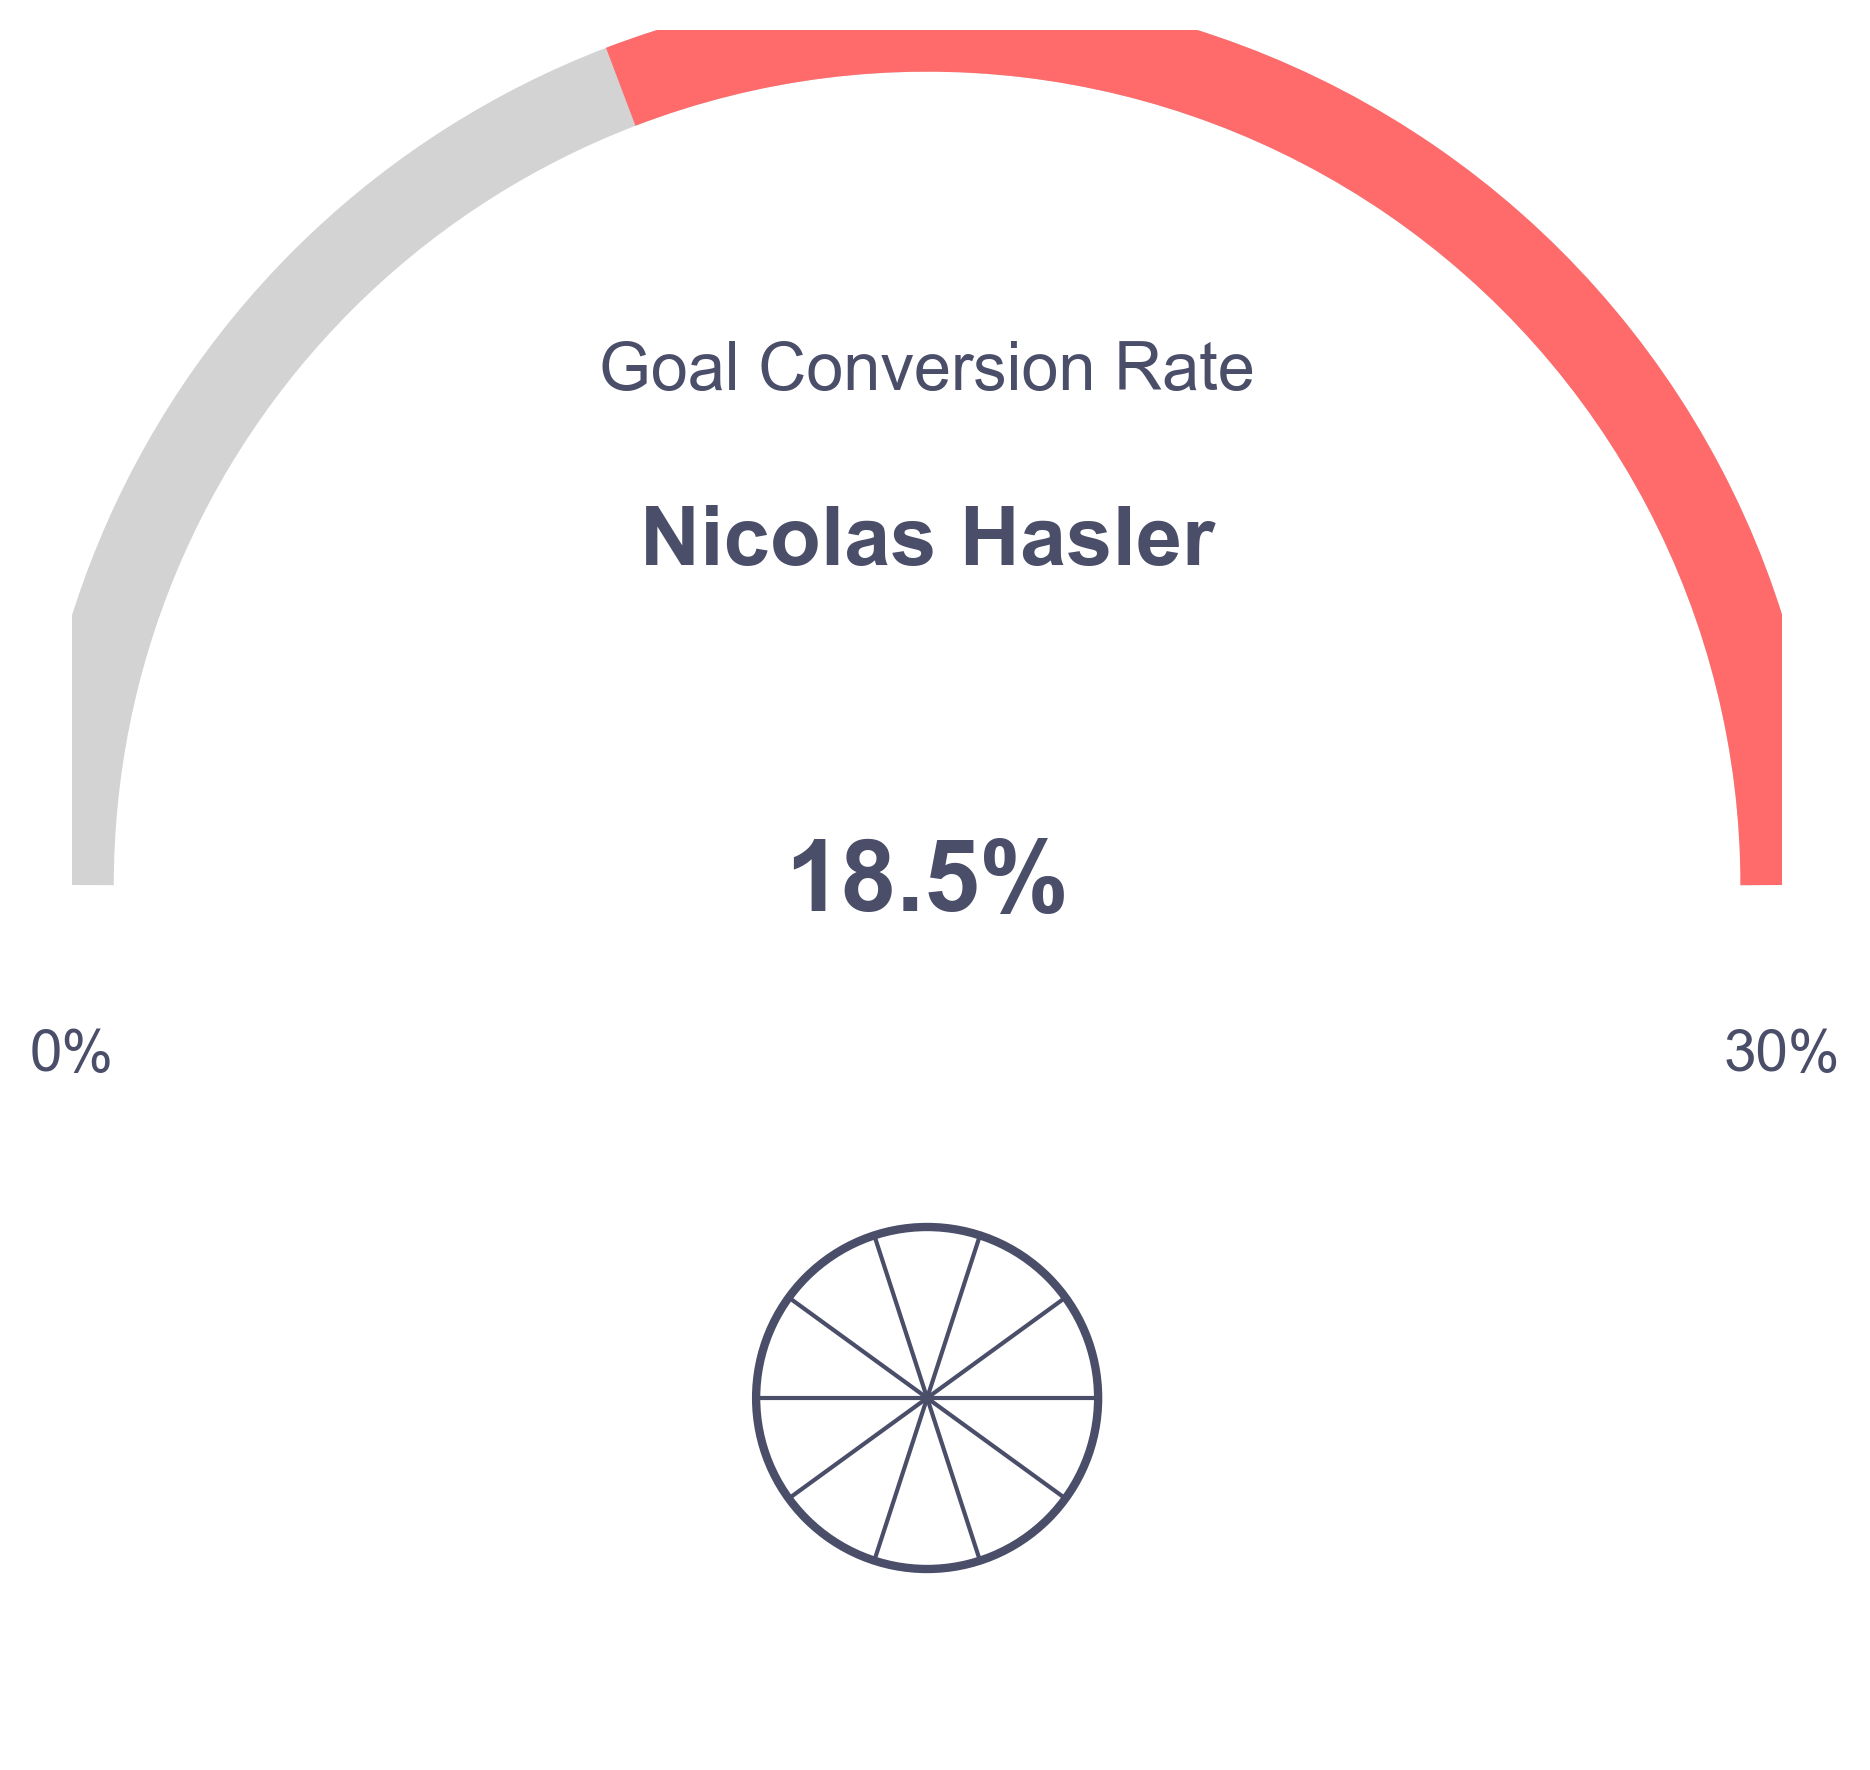What is the goal conversion rate displayed in the figure? The figure shows a numerical value along with a visual representation in the colored arc, which corresponds to the conversion rate. The text inside the central circle states "18.5%".
Answer: 18.5% Who is the top striker for Liechtenstein mentioned in the figure? The text above the central circle in the figure reads "Nicolas Hasler". This identifies the top striker.
Answer: Nicolas Hasler What is the maximum goal conversion rate indicated in the figure? The maximum rate is labeled next to one end of the arc, which is marked as "30%".
Answer: 30% What does the title of the figure say? The title located near the top of the figure reads "Goal Conversion Rate".
Answer: Goal Conversion Rate How many percent is the current goal conversion rate less than the maximum rate? The current rate is displayed as 18.5%, and the maximum rate is 30%. The difference is 30% - 18.5% = 11.5%.
Answer: 11.5% Which parts of the figure display the numerical value 18.5%? The value "18.5%" is shown in the text inside the central circle and visually represented by the length of the colored arc.
Answer: central circle and colored arc What visual elements represent the goal conversion rate on the gauge? The goal conversion rate is represented by a colored arc which extends up to a certain angle, corresponding to the conversion rate.
Answer: colored arc What are the minimum and maximum values labeled on the figure? The minimum value is labeled "0%" and the maximum value is labeled "30%", both positioned at either end of the arc.
Answer: 0% and 30% Is the current goal conversion rate closer to the minimum or the maximum rate? The current rate, 18.5%, is closer to the maximum rate of 30% than the minimum rate of 0%.
Answer: maximum rate By how many degrees does the arc represent the current conversion rate? The conversion rate is scaled to the maximum rate of 30%. With the full arc being 180 degrees, the current rate is represented by (180 degrees * 18.5 / 30) which is 111 degrees.
Answer: 111 degrees 